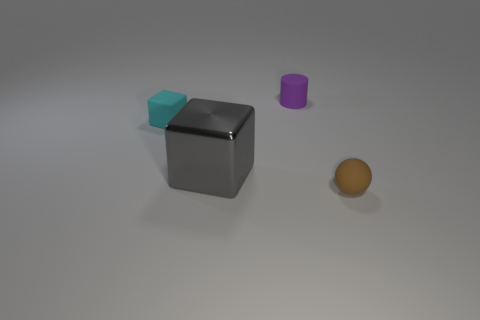Is there a cyan rubber block?
Give a very brief answer. Yes. How many other spheres are the same color as the tiny ball?
Offer a terse response. 0. There is a matte thing that is in front of the matte thing that is to the left of the small purple matte cylinder; what size is it?
Ensure brevity in your answer.  Small. Is there a big purple sphere that has the same material as the purple cylinder?
Make the answer very short. No. There is a ball that is the same size as the purple matte cylinder; what is its material?
Your response must be concise. Rubber. There is a rubber thing in front of the gray metallic thing; does it have the same color as the tiny object that is behind the cyan rubber cube?
Keep it short and to the point. No. Are there any gray cubes that are to the right of the tiny object behind the cyan block?
Your response must be concise. No. Does the matte thing that is to the left of the purple matte cylinder have the same shape as the tiny matte thing that is in front of the tiny cyan rubber thing?
Your response must be concise. No. Is the material of the small object on the left side of the tiny purple cylinder the same as the tiny object on the right side of the small cylinder?
Your answer should be compact. Yes. What is the material of the tiny thing right of the object that is behind the cyan block?
Make the answer very short. Rubber. 